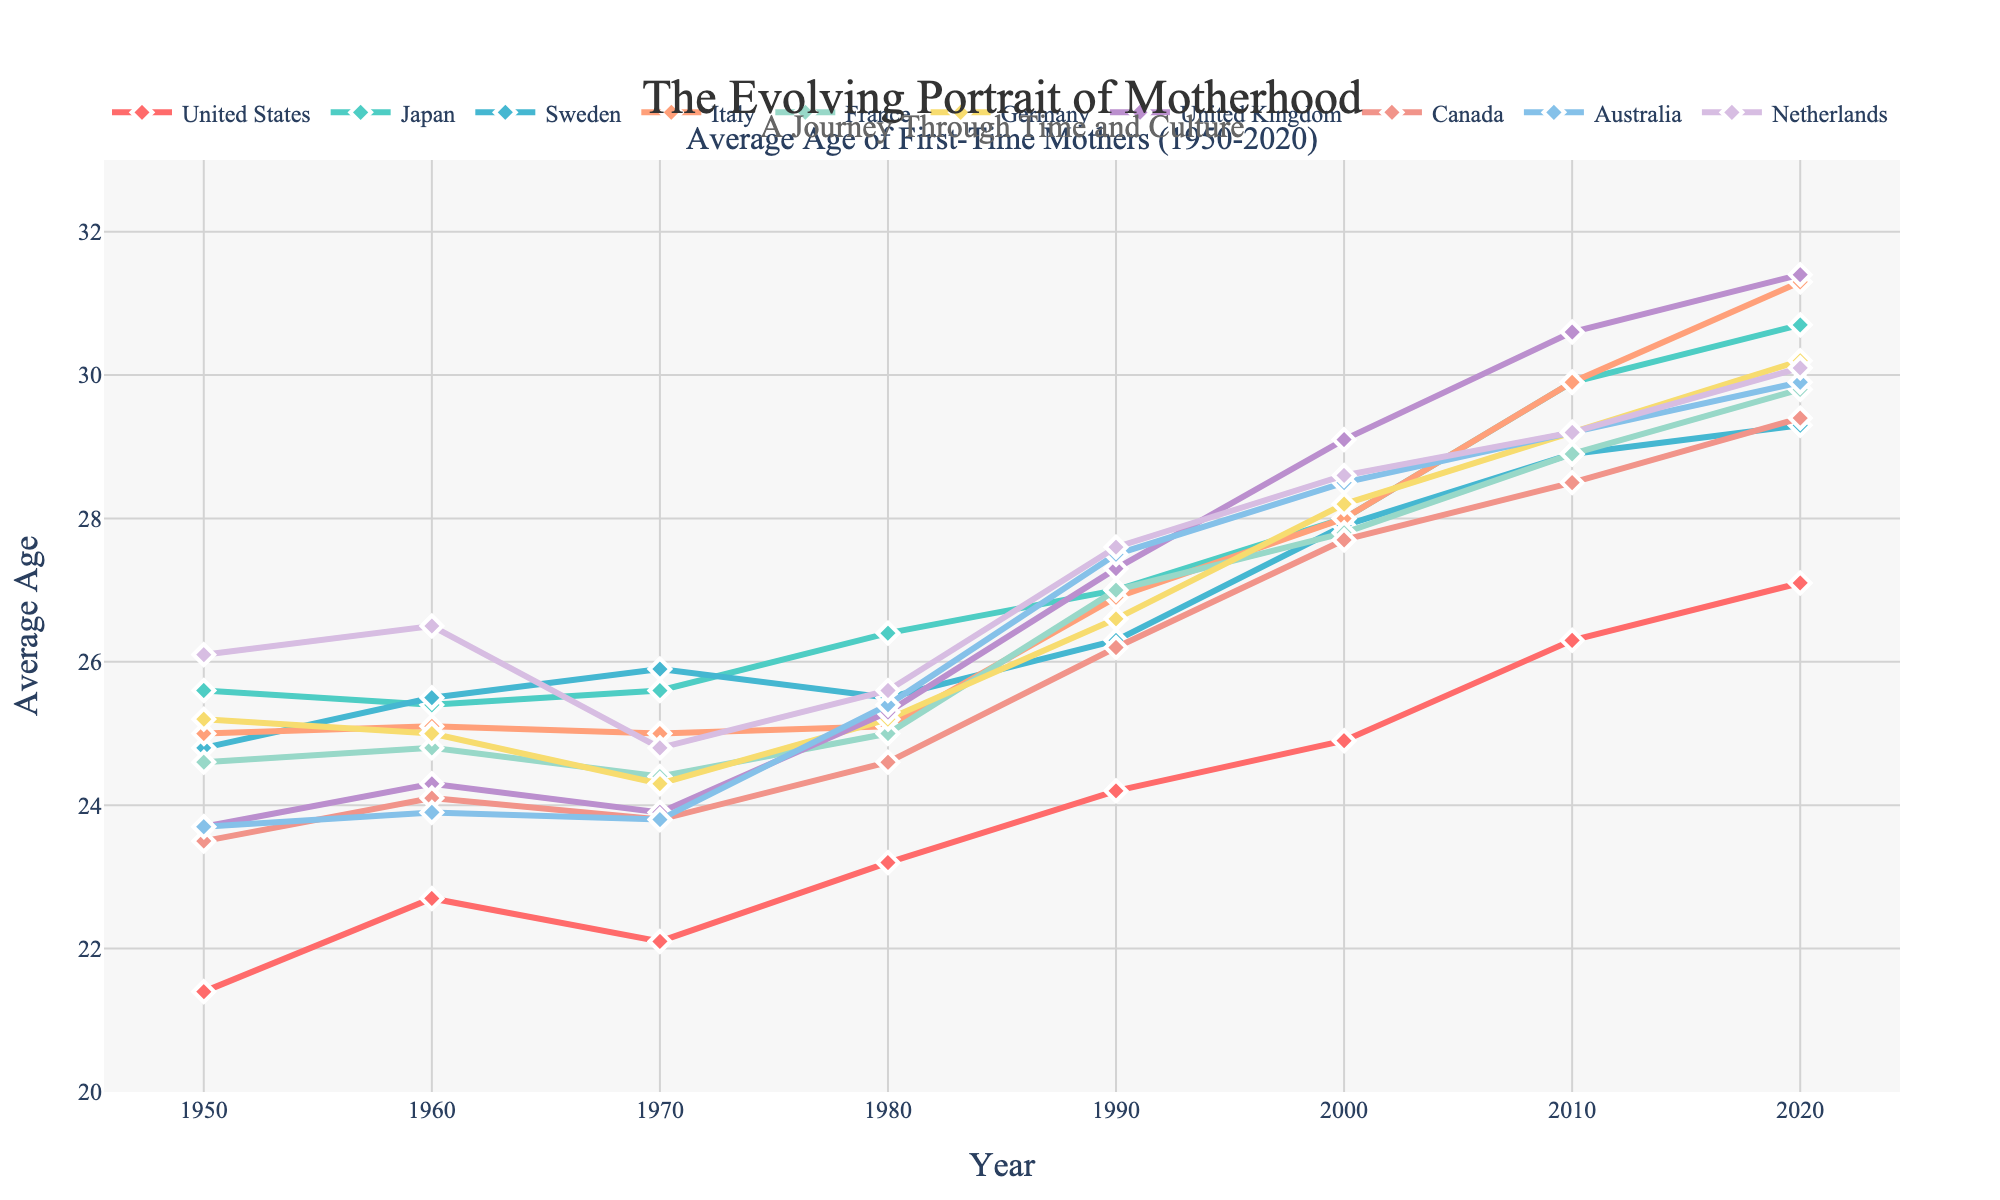What is the general trend in the average age of first-time mothers in Japan from 1950 to 2020? The line representing Japan shows an increasing trend in the average age of first-time mothers from 1950 (around 25.6) to 2020 (around 30.7), suggesting that Japanese women are having their first child at older ages over time.
Answer: Increasing Which country had the highest average age of first-time mothers in 2020? In 2020, the highest average can be spotted at around 31.4 years, which corresponds to the United Kingdom.
Answer: United Kingdom By how many years has the average age of first-time mothers in the United States increased from 1950 to 2020? In 1950, the average age of first-time mothers in the United States was 21.4 years, and by 2020 it had increased to 27.1 years. The difference is 27.1 - 21.4 = 5.7 years.
Answer: 5.7 years Which country showed the least change in the average age of first-time mothers from 1950 to 2020? The line representing Sweden shows the least change, starting around 24.8 in 1950 and ending around 29.3 in 2020, a difference of 4.5 years, which is relatively small compared to other countries.
Answer: Sweden What is the difference in the average age of first-time mothers between France and Germany in 2020? In 2020, the average age for France is around 29.8 years, while for Germany it is around 30.2 years. The difference is 30.2 - 29.8 = 0.4 years.
Answer: 0.4 years Which two countries had the closest average age of first-time mothers in 2000? In 2000, Australia and Canada had very similar average ages of first-time mothers, both around 27.7 and 28.5 years respectively, with a very small difference between them.
Answer: Australia and Canada How much did the average age of first-time mothers in Italy change between 1970 and 2020? In 1970, the average age in Italy was around 25.0 years, and by 2020 it was around 31.3 years. The difference is 31.3 - 25.0 = 6.3 years.
Answer: 6.3 years Which country's data shows a decrease in the average age of first-time mothers between 2010 and 2020? None of the countries' lines on the graph shows a decrease in the average age between 2010 and 2020; all lines either plateau or increase.
Answer: None Is there any country which had a decline in the average age of first-time mothers between 1960 and 1970? The graph shows that in the United States, the average age decreased slightly from around 22.7 in 1960 to around 22.1 in 1970.
Answer: United States 